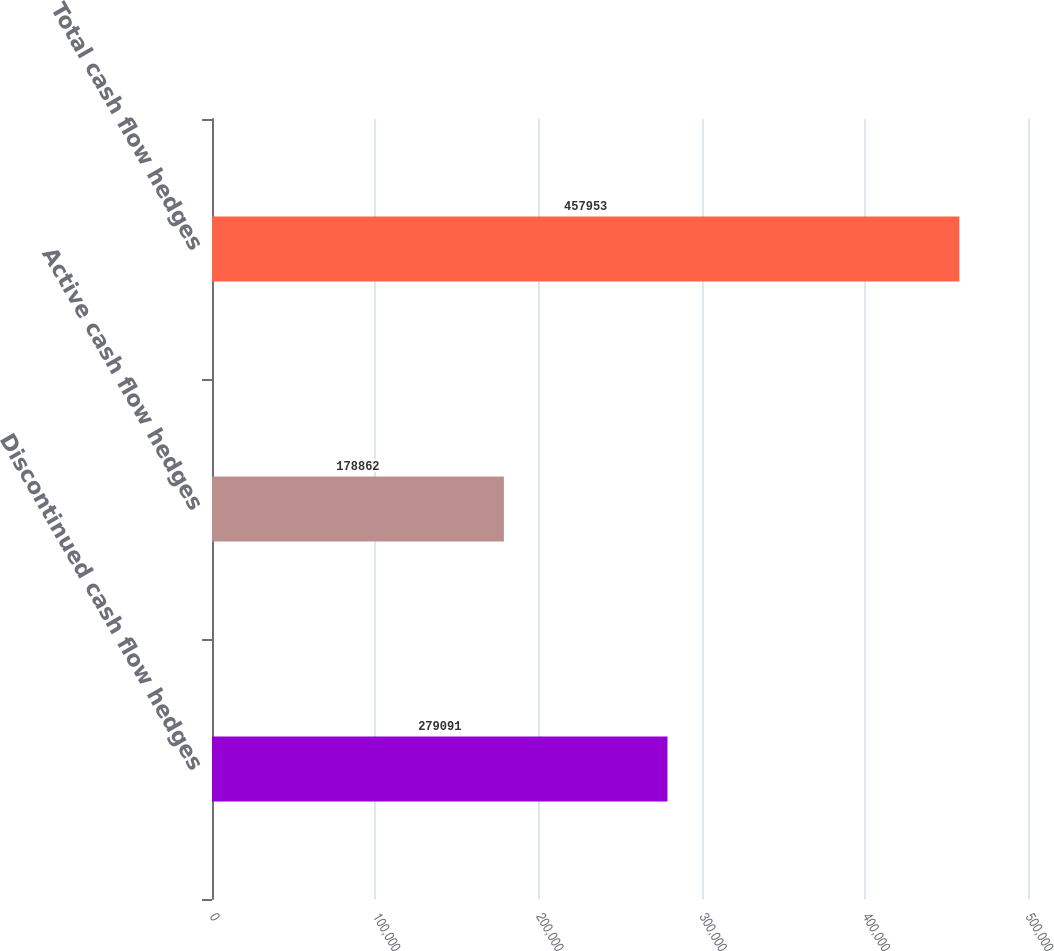Convert chart. <chart><loc_0><loc_0><loc_500><loc_500><bar_chart><fcel>Discontinued cash flow hedges<fcel>Active cash flow hedges<fcel>Total cash flow hedges<nl><fcel>279091<fcel>178862<fcel>457953<nl></chart> 